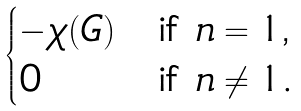Convert formula to latex. <formula><loc_0><loc_0><loc_500><loc_500>\begin{cases} - \chi ( G ) & \text {if $n = 1$,} \\ 0 & \text {if $n \ne 1$. } \end{cases}</formula> 